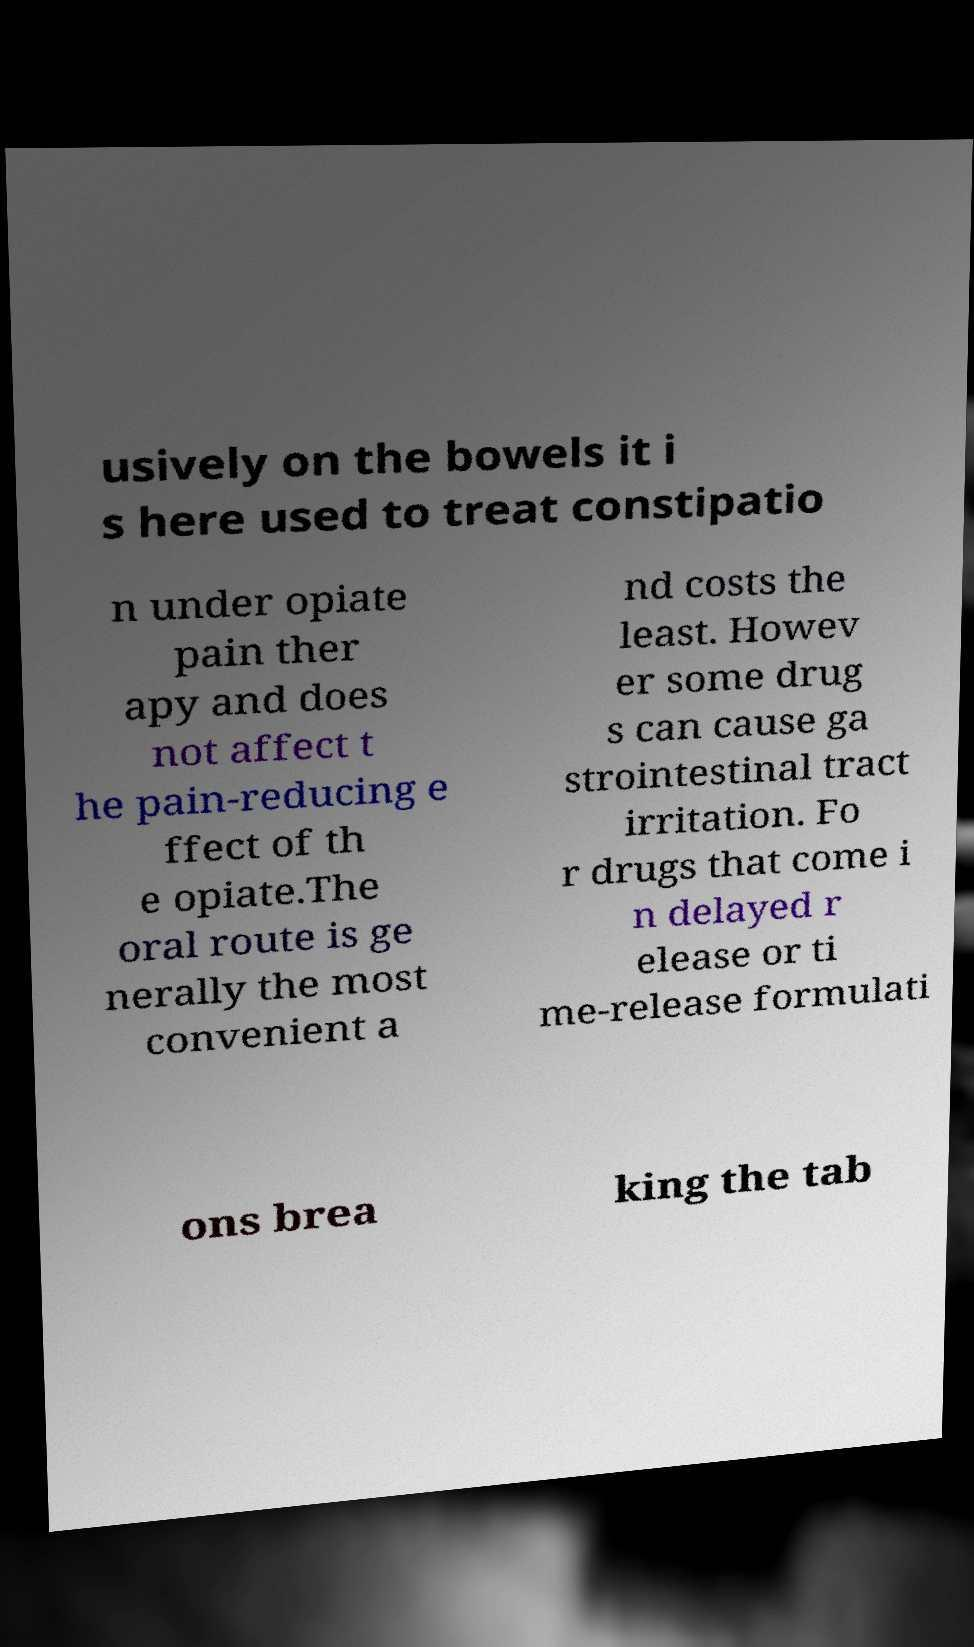Could you extract and type out the text from this image? usively on the bowels it i s here used to treat constipatio n under opiate pain ther apy and does not affect t he pain-reducing e ffect of th e opiate.The oral route is ge nerally the most convenient a nd costs the least. Howev er some drug s can cause ga strointestinal tract irritation. Fo r drugs that come i n delayed r elease or ti me-release formulati ons brea king the tab 